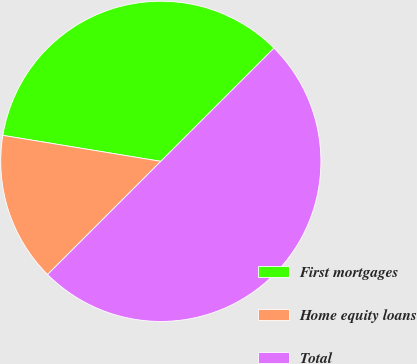<chart> <loc_0><loc_0><loc_500><loc_500><pie_chart><fcel>First mortgages<fcel>Home equity loans<fcel>Total<nl><fcel>34.91%<fcel>15.09%<fcel>50.0%<nl></chart> 